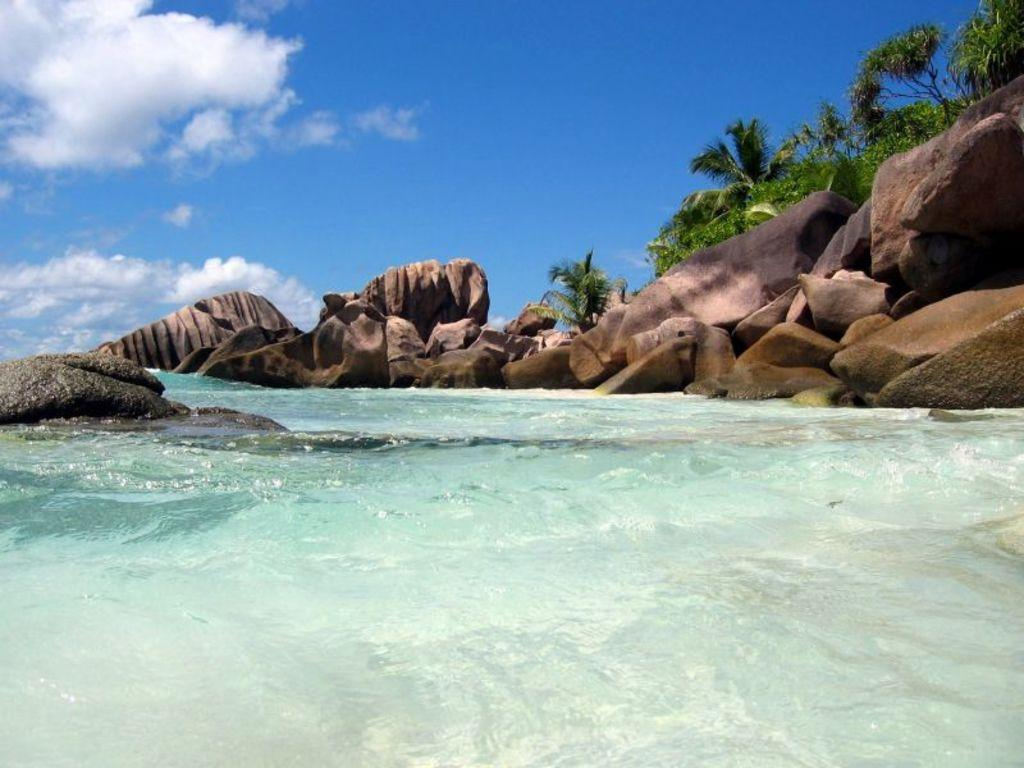What is present at the bottom of the image? There is water at the bottom of the image. What can be seen on the right side of the image? There are rocks and trees on the right side of the image. What is present on the left side of the image? There are rocks on the left side of the image. What type of advertisement can be seen on the rocks in the image? There is no advertisement present in the image; it only features rocks, trees, and water. What is the title of the image? The image does not have a title, as it is a visual representation and not a written work. 